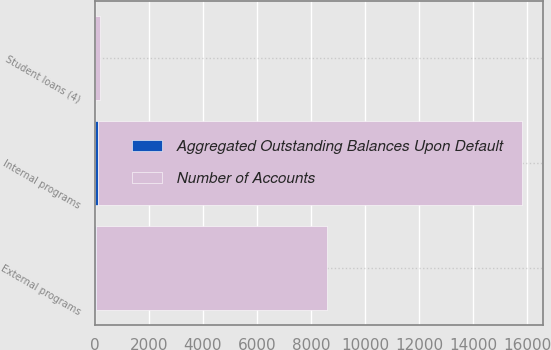<chart> <loc_0><loc_0><loc_500><loc_500><stacked_bar_chart><ecel><fcel>Internal programs<fcel>External programs<fcel>Student loans (4)<nl><fcel>Number of Accounts<fcel>15703<fcel>8543<fcel>172<nl><fcel>Aggregated Outstanding Balances Upon Default<fcel>106<fcel>40<fcel>4<nl></chart> 